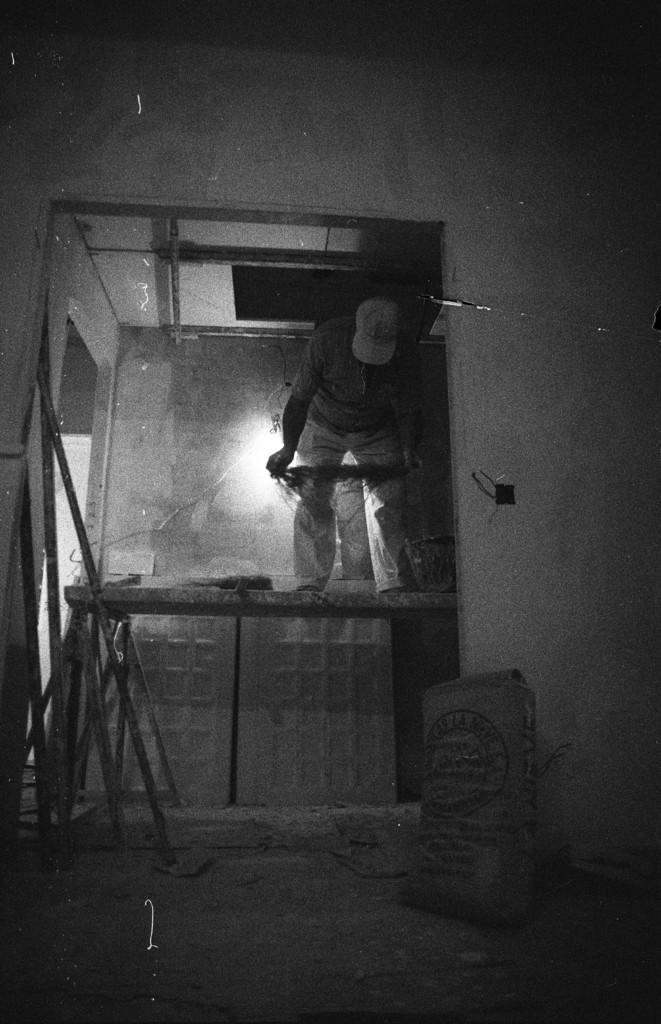Can you describe this image briefly? This is a black and white image. We can see a person is standing on an object. On the left side of the image, it looks like a ladder and some objects. On the floor, it looks like a sack. Behind the man, there is light. At the top of the image, there is a wall. 